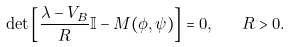<formula> <loc_0><loc_0><loc_500><loc_500>\det \left [ \frac { \lambda - V _ { B } } { R } \mathbb { I } - M ( \phi , \psi ) \right ] = 0 , \quad R > 0 .</formula> 